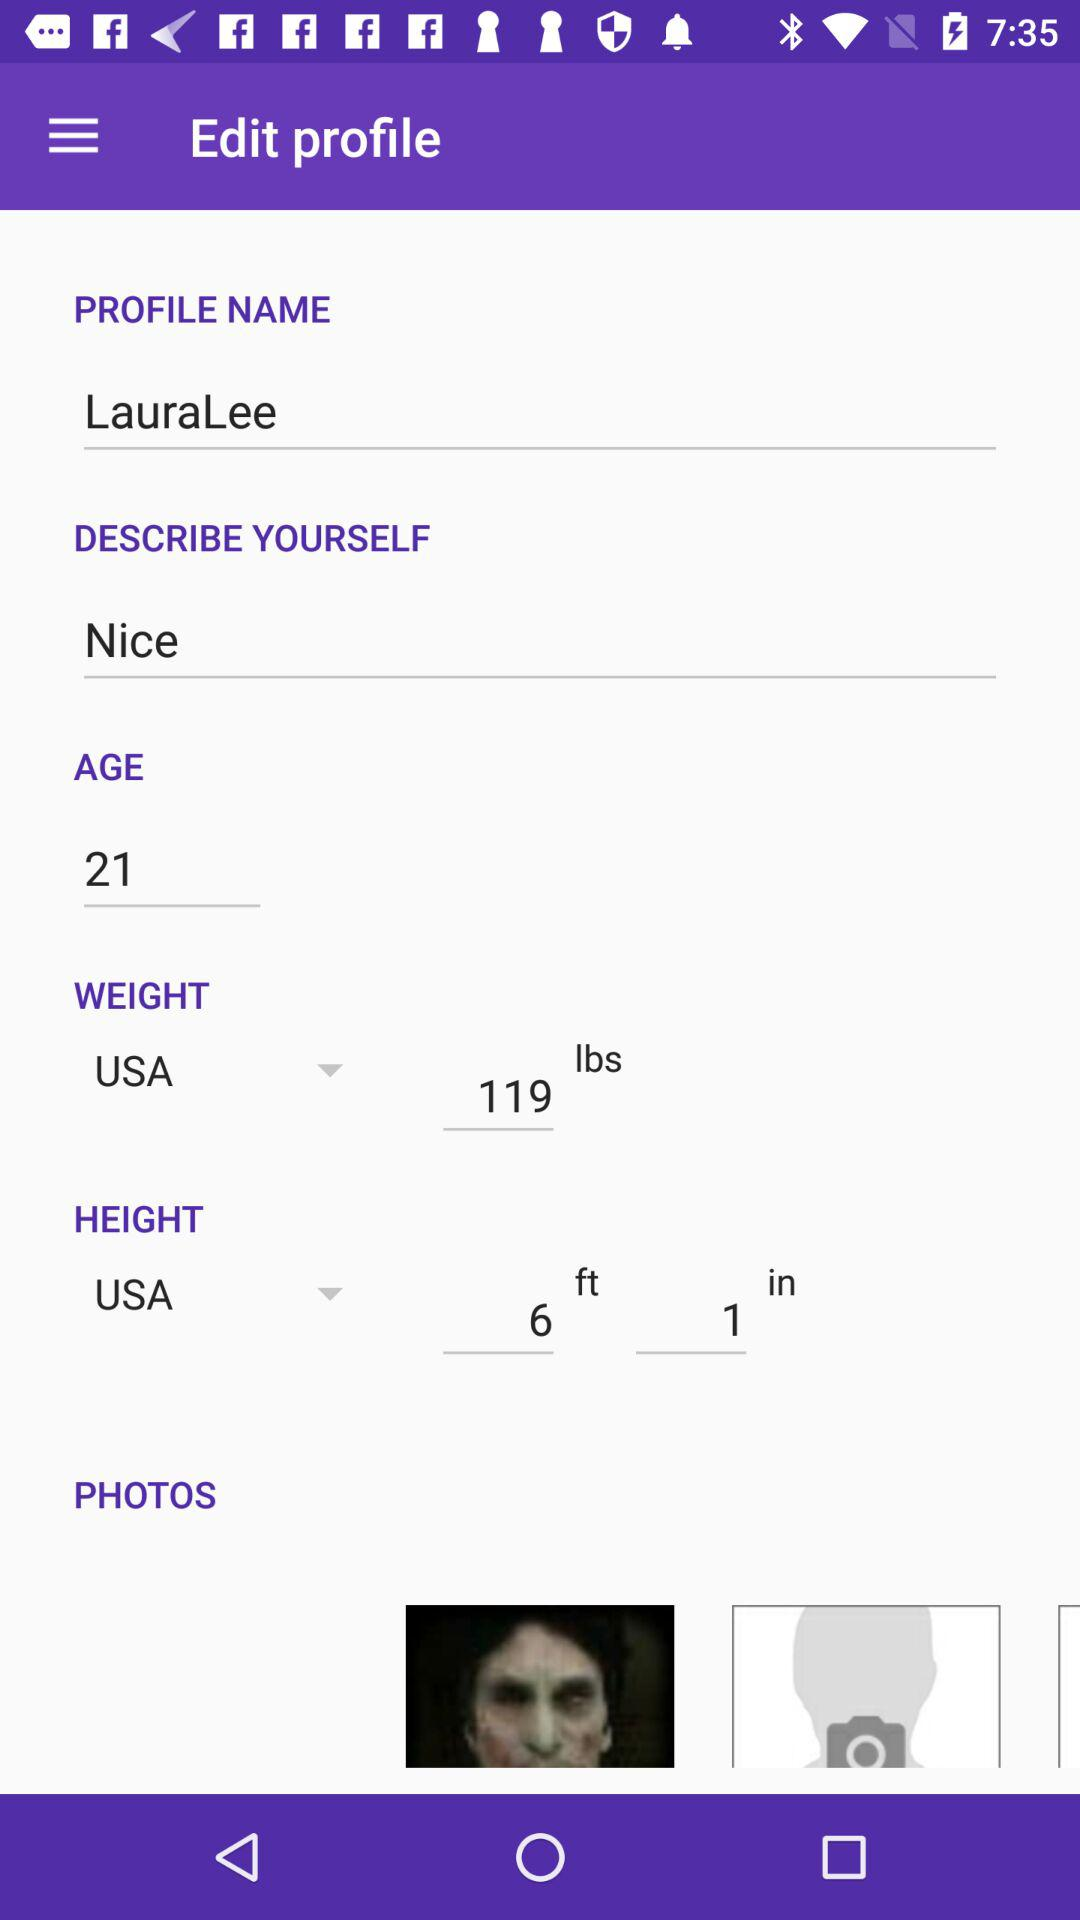What is the given age? The given age is 21. 